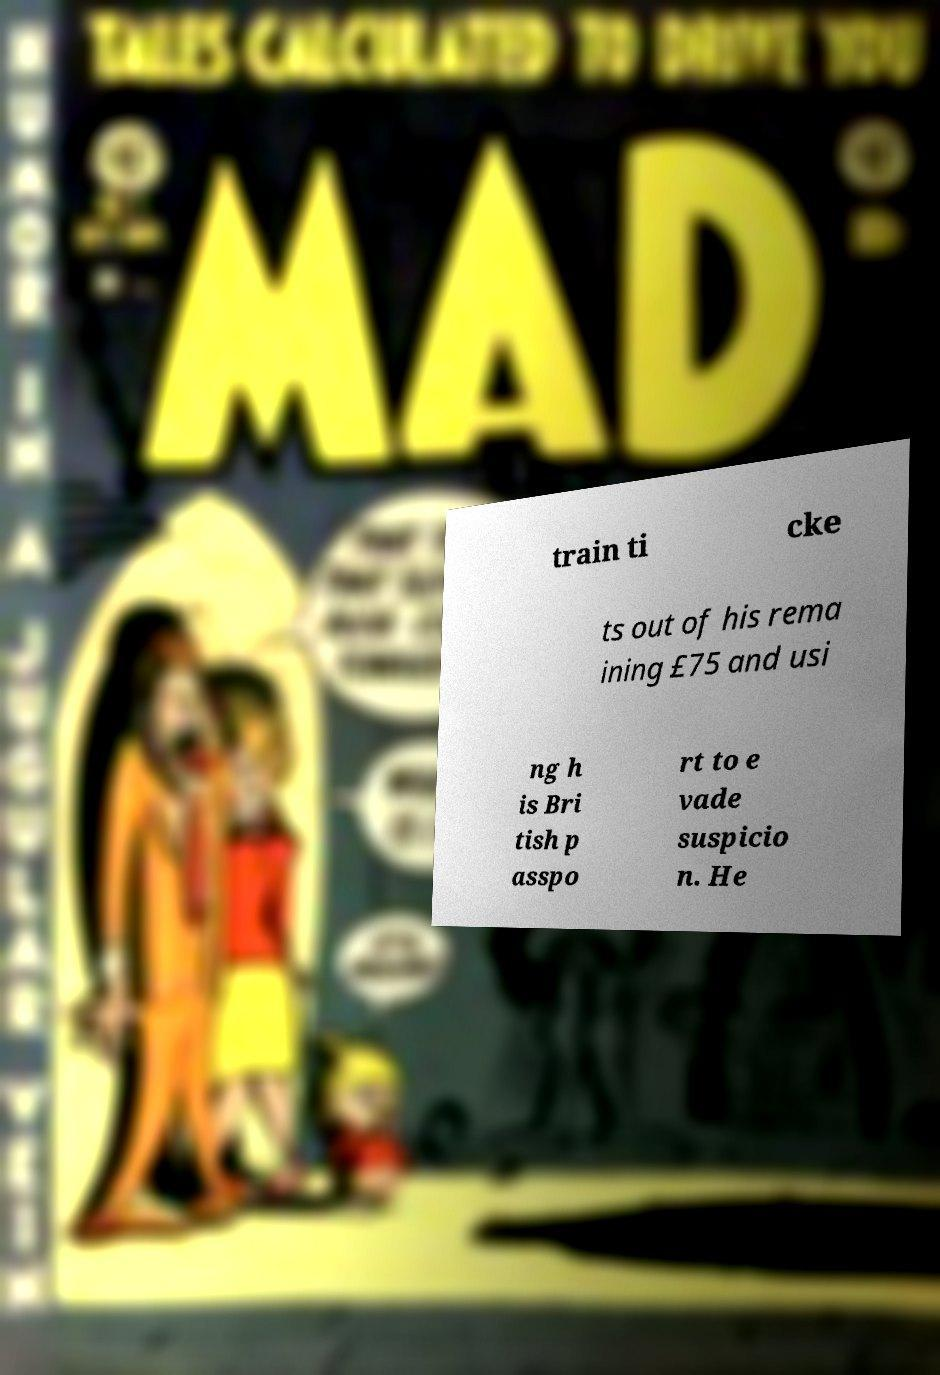What messages or text are displayed in this image? I need them in a readable, typed format. train ti cke ts out of his rema ining £75 and usi ng h is Bri tish p asspo rt to e vade suspicio n. He 